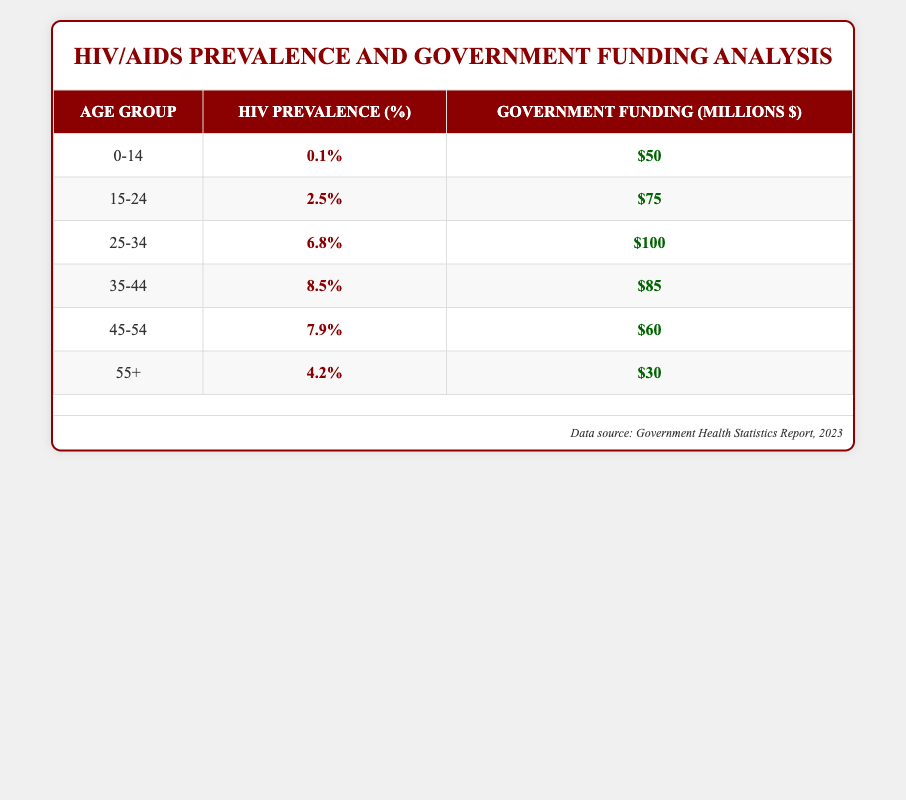What is the HIV prevalence percentage for the age group 25-34? The table states that the HIV prevalence percentage for the age group of 25-34 is listed directly as 6.8%.
Answer: 6.8% How much government funding is allocated to the age group 55+? According to the table, the amount of government funding allocated to the age group 55 and over is given as $30 million.
Answer: $30 million Which age group has the highest HIV prevalence percentage? By examining the HIV prevalence percentages in the table, the age group 35-44 has the highest prevalence at 8.5%.
Answer: 35-44 What is the total government funding for the age groups 15-24 and 45-54 combined? To find the total government funding for these age groups, we add the funding amounts: 15-24 ($75 million) + 45-54 ($60 million) = $135 million.
Answer: $135 million Is the HIV prevalence percentage for the age group 0-14 higher than that for the group 55+? The table shows that the HIV prevalence for 0-14 is 0.1%, and for 55+, it is 4.2%. Thus, 0.1% is not higher than 4.2%.
Answer: No What is the average HIV prevalence percentage across all age groups? Calculating the average requires summing all percentages: (0.1 + 2.5 + 6.8 + 8.5 + 7.9 + 4.2) = 29.0%. Dividing by the number of age groups (6) results in an average of 29.0 / 6 = 4.83%.
Answer: 4.83% Which age group receives less government funding, 55+ or 0-14? Looking at the funding amounts, 55+ has $30 million and 0-14 has $50 million. Since $30 million is less than $50 million, 55+ receives less funding.
Answer: 55+ What is the difference in government funding between the age groups 25-34 and 15-24? The funding for 25-34 is $100 million, and for 15-24 it is $75 million. The difference is $100 million - $75 million = $25 million.
Answer: $25 million 